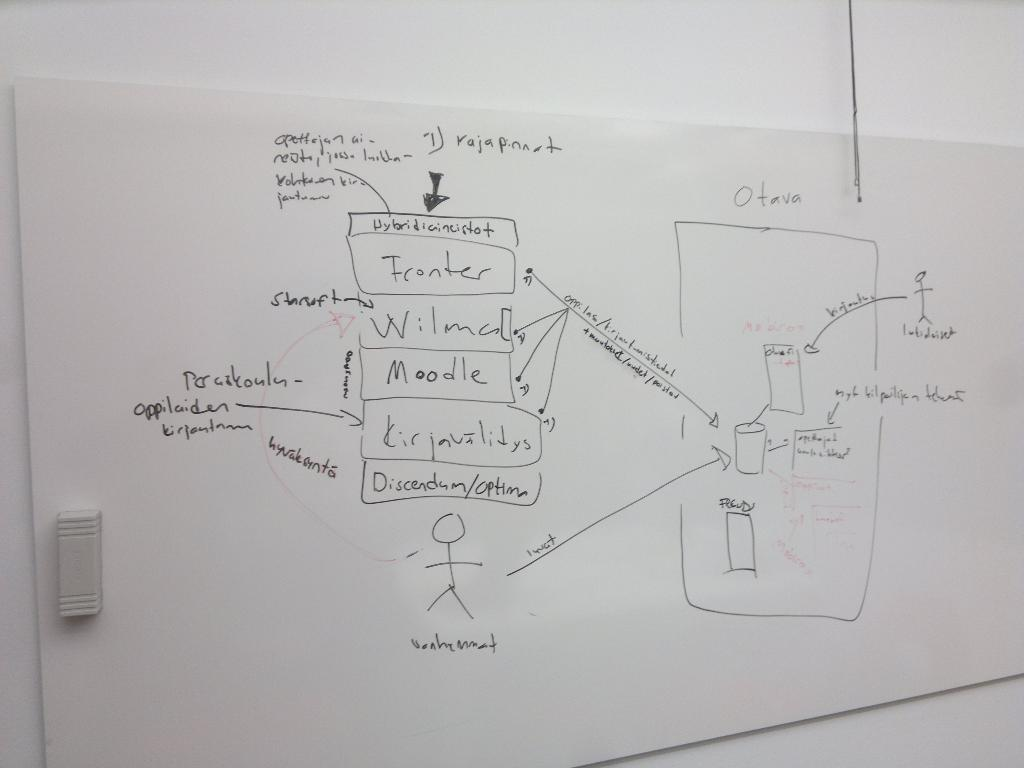<image>
Relay a brief, clear account of the picture shown. A diagram on a white board shows various processes, such as Moodle, and Franker. 